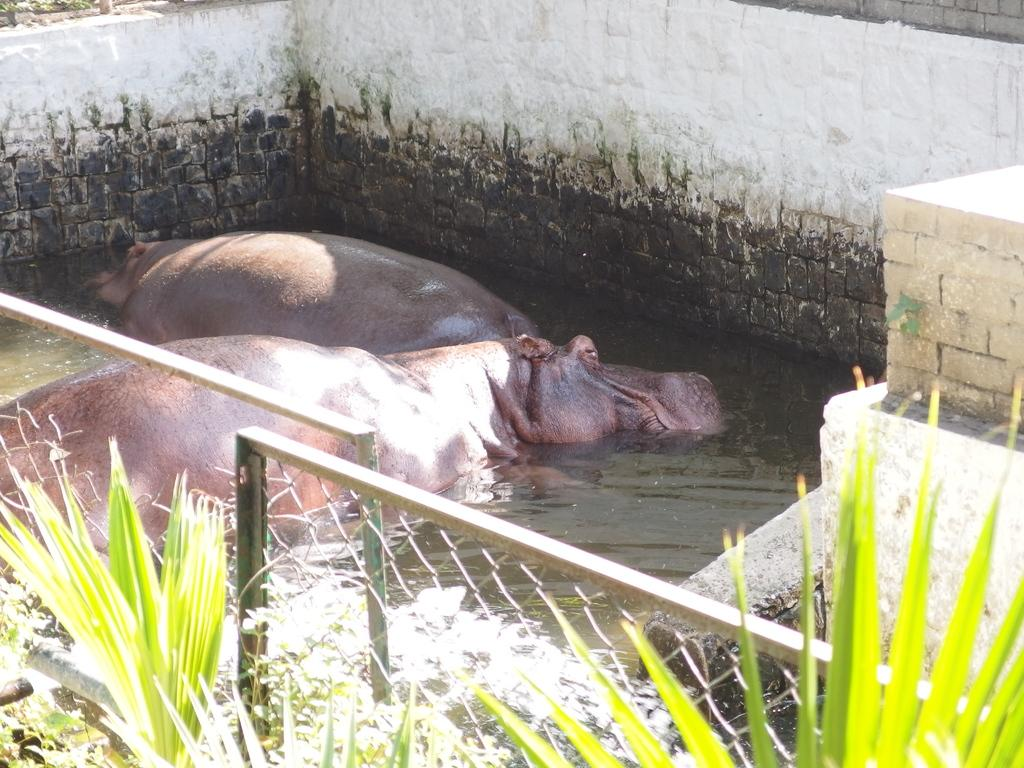What animals can be seen in the water in the image? There are hippopotamuses in the water in the image. What type of material is present in the image? There is a mesh in the image. What can be found in front of the mesh? There are plants in front of the mesh. What type of cobweb can be seen in the image? There is no cobweb present in the image. What type of birds can be seen flying in the image? There are no birds visible in the image. 